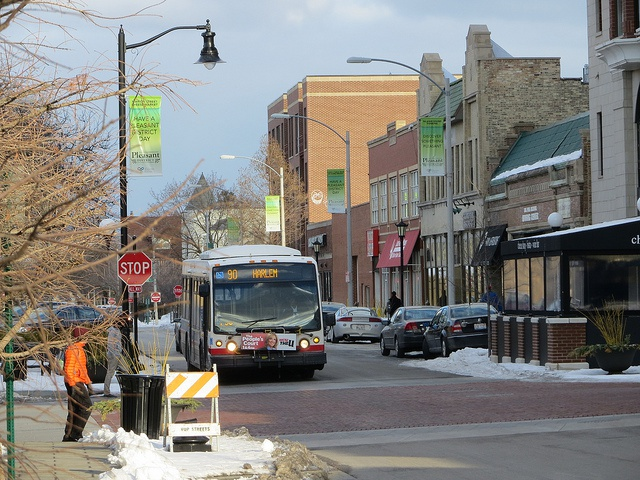Describe the objects in this image and their specific colors. I can see bus in black, gray, darkgray, and blue tones, car in black, gray, and blue tones, people in black, red, and maroon tones, car in black, gray, darkgray, and tan tones, and car in black, gray, and darkgray tones in this image. 